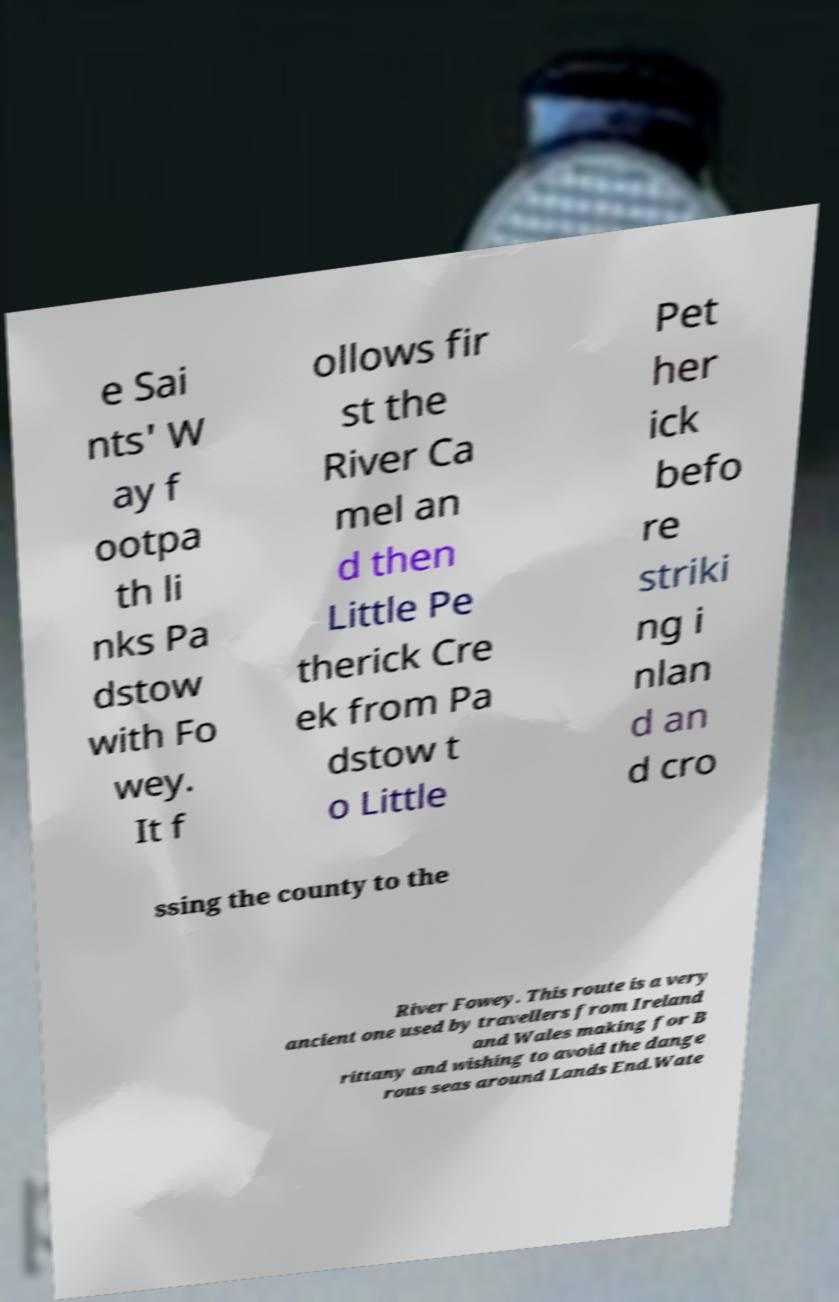Could you assist in decoding the text presented in this image and type it out clearly? e Sai nts' W ay f ootpa th li nks Pa dstow with Fo wey. It f ollows fir st the River Ca mel an d then Little Pe therick Cre ek from Pa dstow t o Little Pet her ick befo re striki ng i nlan d an d cro ssing the county to the River Fowey. This route is a very ancient one used by travellers from Ireland and Wales making for B rittany and wishing to avoid the dange rous seas around Lands End.Wate 